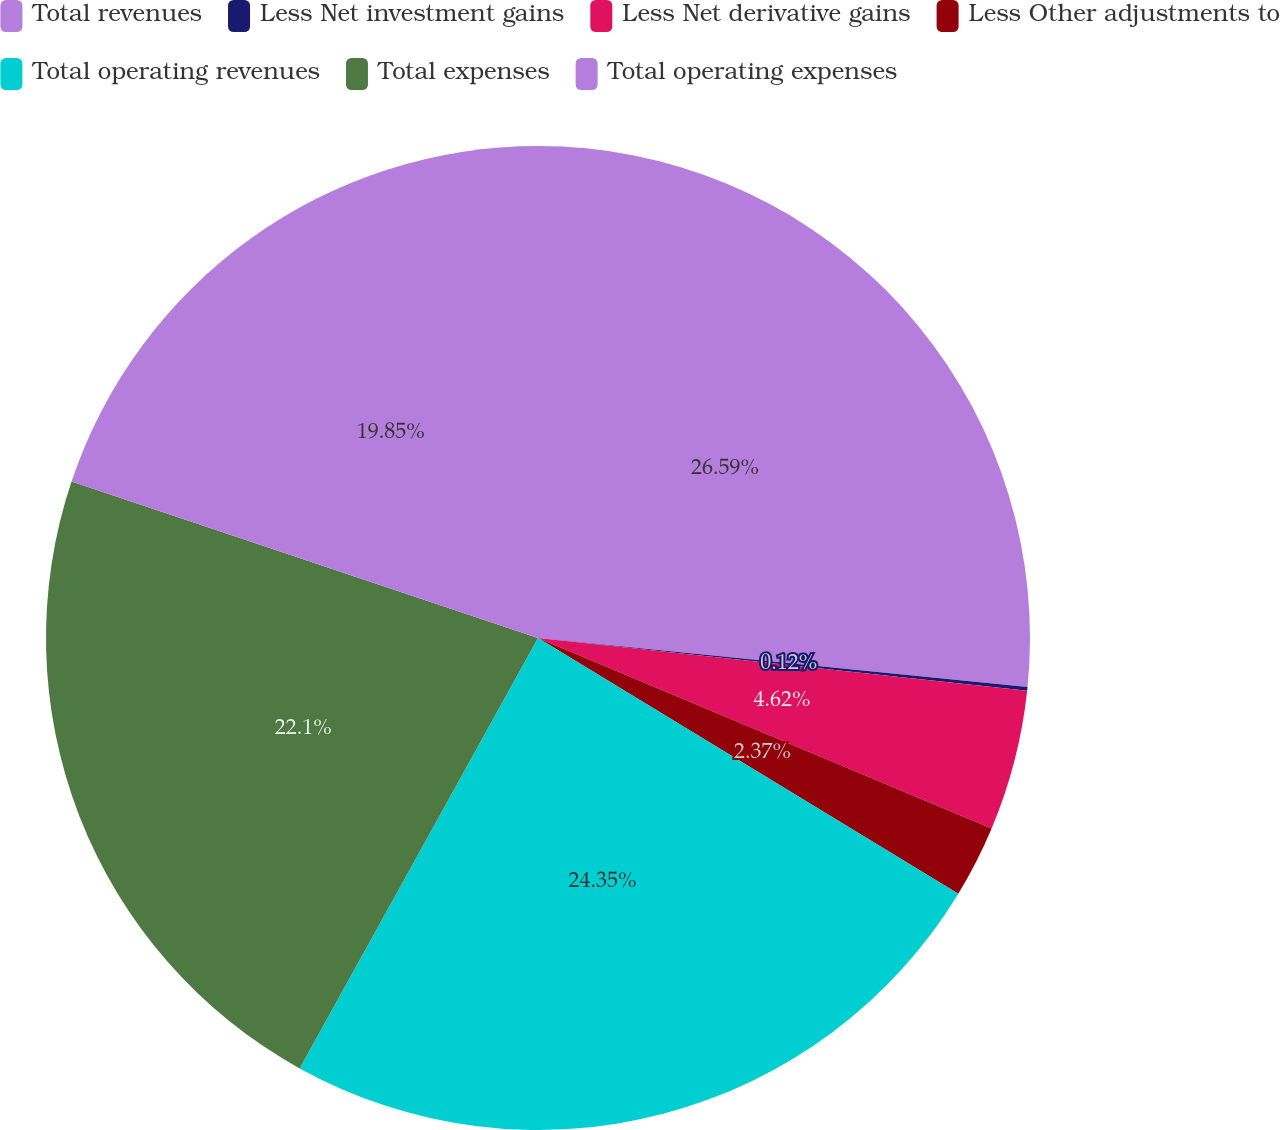Convert chart. <chart><loc_0><loc_0><loc_500><loc_500><pie_chart><fcel>Total revenues<fcel>Less Net investment gains<fcel>Less Net derivative gains<fcel>Less Other adjustments to<fcel>Total operating revenues<fcel>Total expenses<fcel>Total operating expenses<nl><fcel>26.59%<fcel>0.12%<fcel>4.62%<fcel>2.37%<fcel>24.35%<fcel>22.1%<fcel>19.85%<nl></chart> 